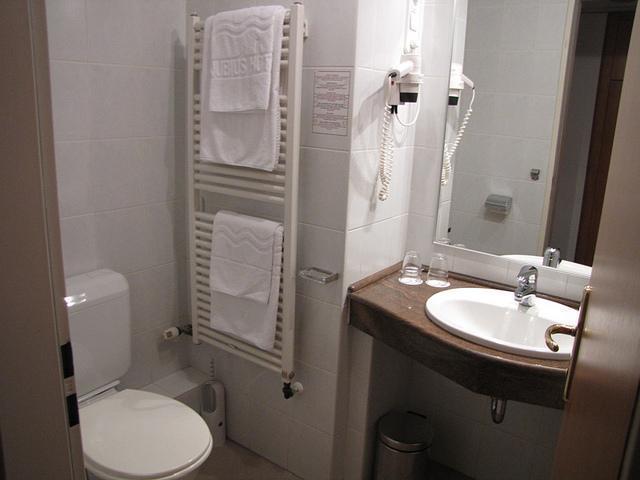How many sinks are in the picture?
Give a very brief answer. 1. How many zebra are standing in unison?
Give a very brief answer. 0. 